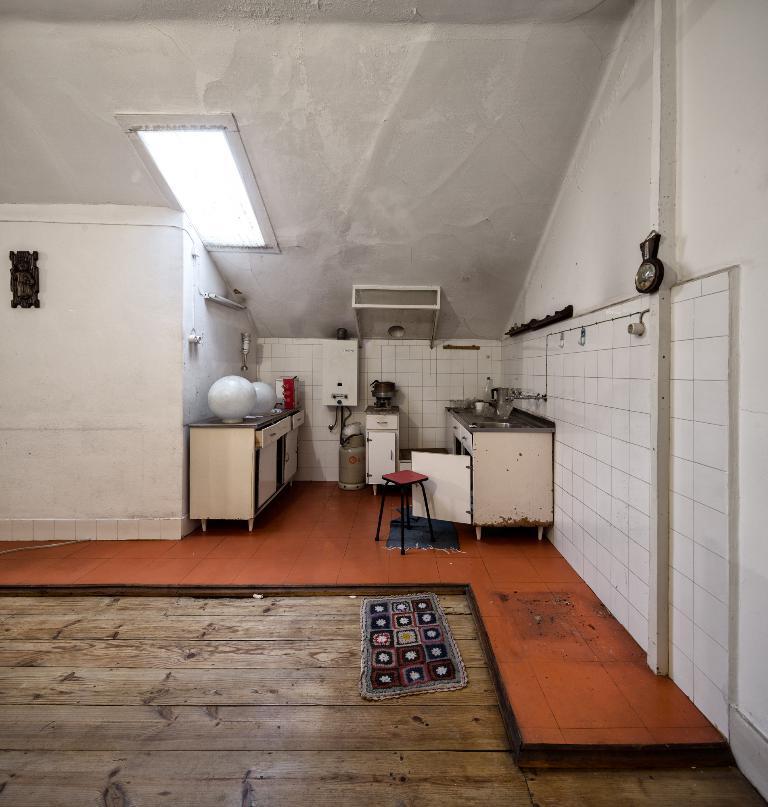Can you describe this image briefly? In this image we can see the inner view of a room. In the room we can see sink, taps, stool, cabinets, electric equipment, doormat and an electric light to the roof. 